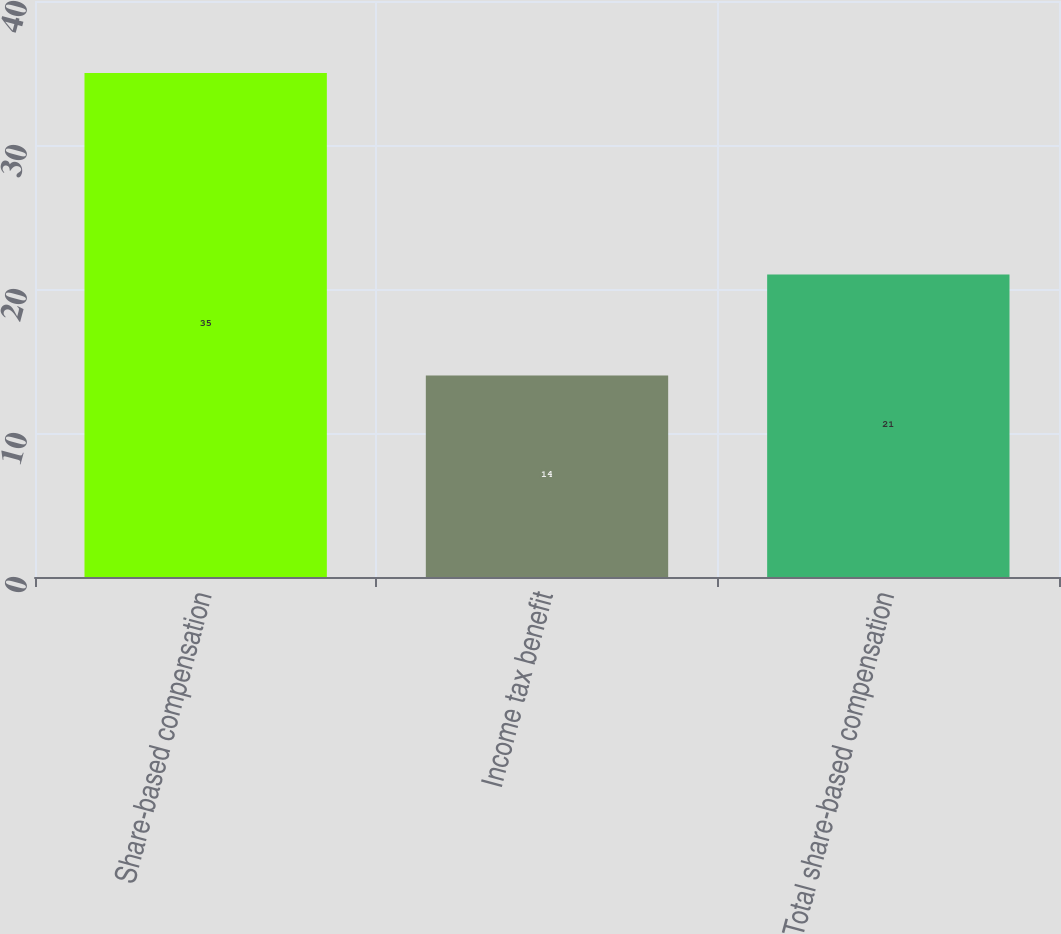<chart> <loc_0><loc_0><loc_500><loc_500><bar_chart><fcel>Share-based compensation<fcel>Income tax benefit<fcel>Total share-based compensation<nl><fcel>35<fcel>14<fcel>21<nl></chart> 